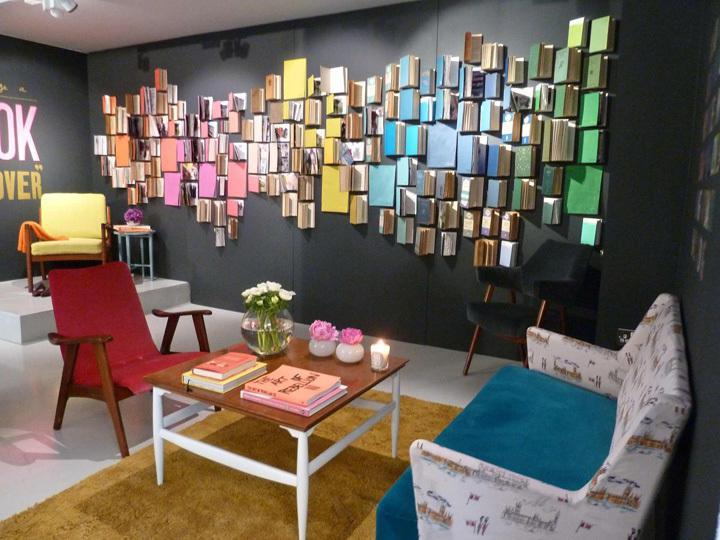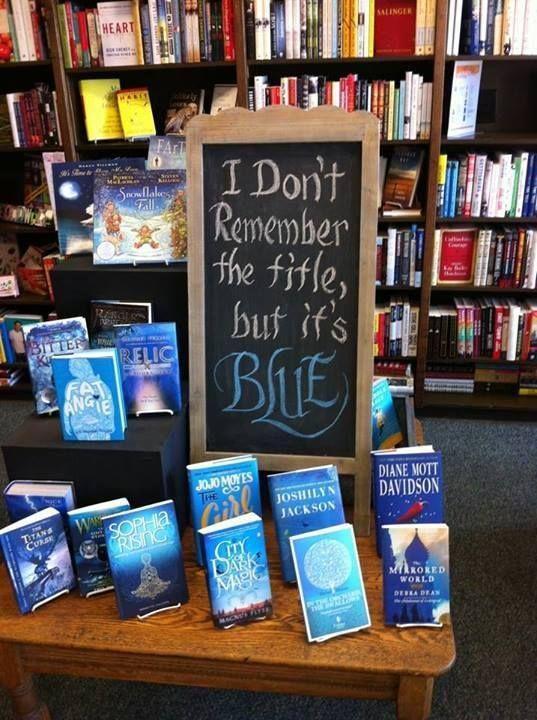The first image is the image on the left, the second image is the image on the right. Assess this claim about the two images: "One image features a bookstore exterior showing a lighted interior, and something upright is outside in front of the store window.". Correct or not? Answer yes or no. No. The first image is the image on the left, the second image is the image on the right. Assess this claim about the two images: "one of the two images contains books in chromatic order; there appears to be a rainbow effect created with books.". Correct or not? Answer yes or no. Yes. 